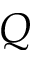Convert formula to latex. <formula><loc_0><loc_0><loc_500><loc_500>Q</formula> 